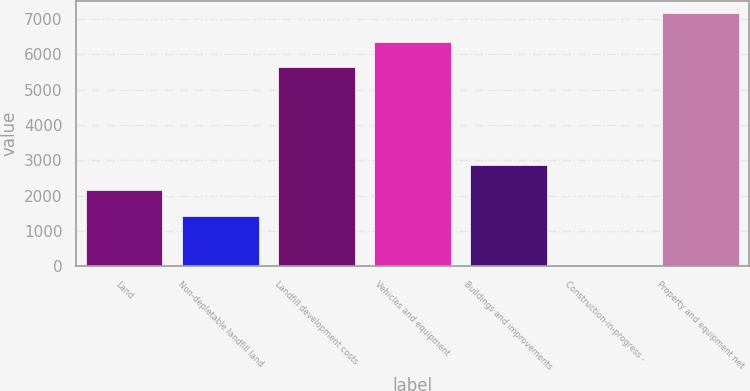Convert chart. <chart><loc_0><loc_0><loc_500><loc_500><bar_chart><fcel>Land<fcel>Non-depletable landfill land<fcel>Landfill development costs<fcel>Vehicles and equipment<fcel>Buildings and improvements<fcel>Construction-in-progress -<fcel>Property and equipment net<nl><fcel>2156.66<fcel>1441.14<fcel>5645.3<fcel>6360.82<fcel>2872.18<fcel>10.1<fcel>7165.3<nl></chart> 